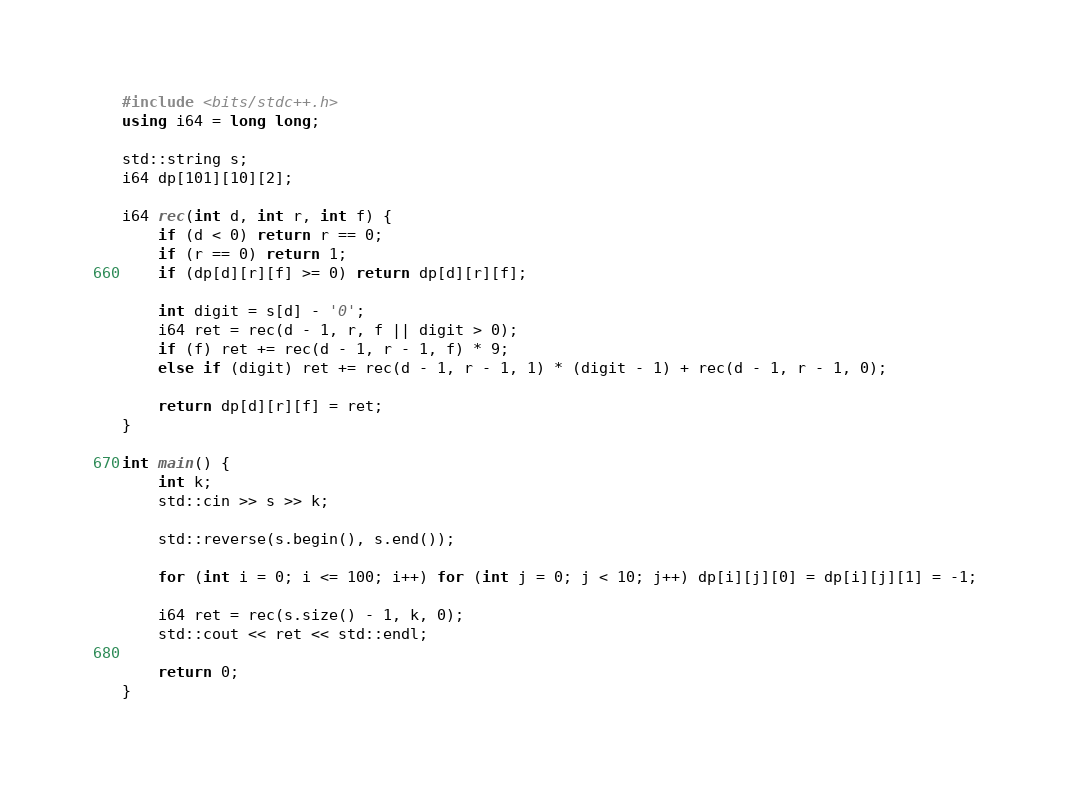Convert code to text. <code><loc_0><loc_0><loc_500><loc_500><_C++_>#include <bits/stdc++.h>
using i64 = long long;

std::string s;
i64 dp[101][10][2];

i64 rec(int d, int r, int f) {
    if (d < 0) return r == 0;
    if (r == 0) return 1;
    if (dp[d][r][f] >= 0) return dp[d][r][f];

    int digit = s[d] - '0';
    i64 ret = rec(d - 1, r, f || digit > 0);
    if (f) ret += rec(d - 1, r - 1, f) * 9;
    else if (digit) ret += rec(d - 1, r - 1, 1) * (digit - 1) + rec(d - 1, r - 1, 0);

    return dp[d][r][f] = ret;
}

int main() {
    int k;
    std::cin >> s >> k;

    std::reverse(s.begin(), s.end());

    for (int i = 0; i <= 100; i++) for (int j = 0; j < 10; j++) dp[i][j][0] = dp[i][j][1] = -1;

    i64 ret = rec(s.size() - 1, k, 0);
    std::cout << ret << std::endl;

    return 0;
}
</code> 